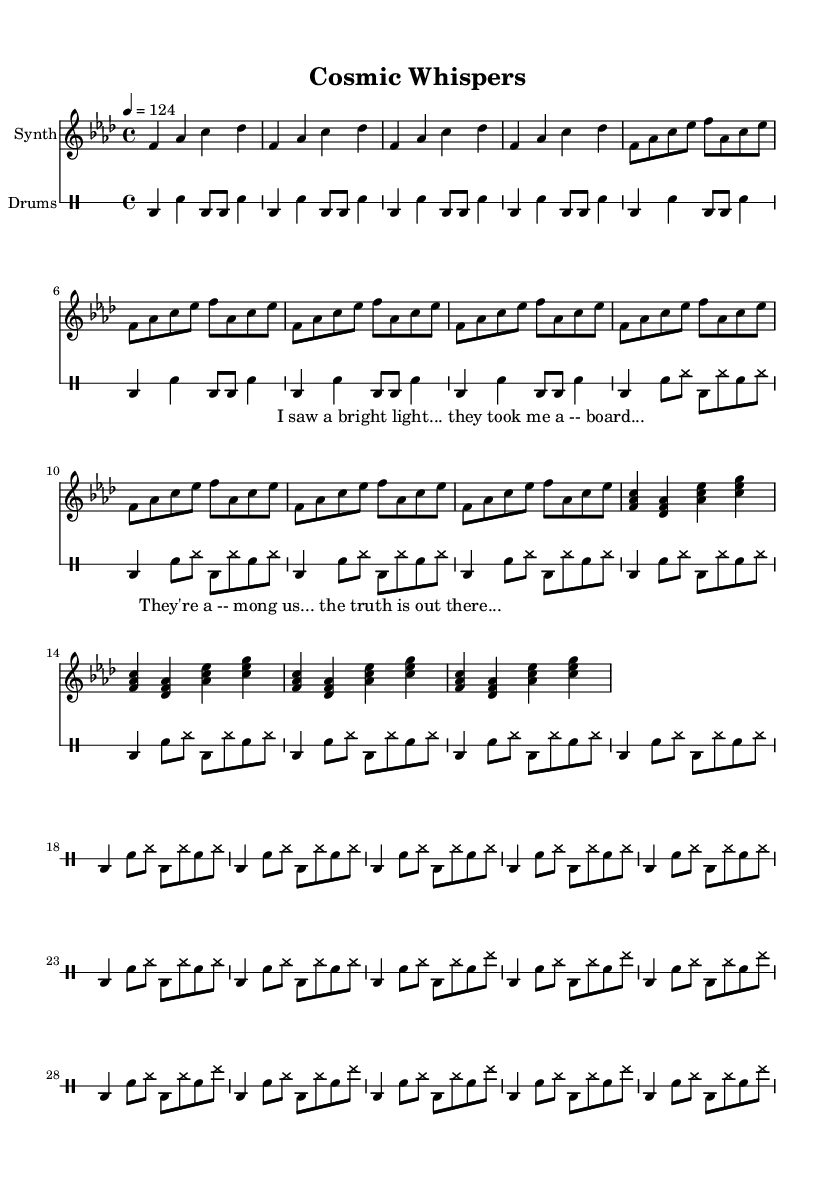What is the key signature of this music? The key signature is F minor, which has four flats (B, E, A, and D) and is indicated at the beginning of the score.
Answer: F minor What is the time signature? The time signature is 4/4, which indicates that there are four beats in each measure and the quarter note gets one beat. This is stated at the beginning of the score.
Answer: 4/4 What is the tempo marking of the piece? The tempo marking is 124 beats per minute and is indicated in the score with the instruction "4 = 124". This tells the performer the speed at which to play the music.
Answer: 124 How many measures are in the synth verse section? The synth verse section has 8 measures, as it repeats a 4-measure pattern twice (indicated by the "repeat unfold 4" command).
Answer: 8 What kind of instruments are used in this score? The score features a Synth and Drums as indicated in the instrument names at the beginning of each staff. The specific parts for each are laid out separately.
Answer: Synth and Drums What is the lyrical content of the chorus? The chorus contains the lyrics "They're a -- mong us... the truth is out there..." which express a thematic connection to the subject of alien abduction. This is reflected in the speech part of the score.
Answer: "They're a -- mong us... the truth is out there..." How does the structure of this piece reflect typical elements of deep house music? The structure includes a classic combination of repetitive synth patterns and drum beats, with lyrical content that engages with a narrative, typical of deep house music. The sections are organized into verses and choruses, maintaining a danceable rhythm while conveying a unique theme.
Answer: Repetitive synth patterns and drum beats 